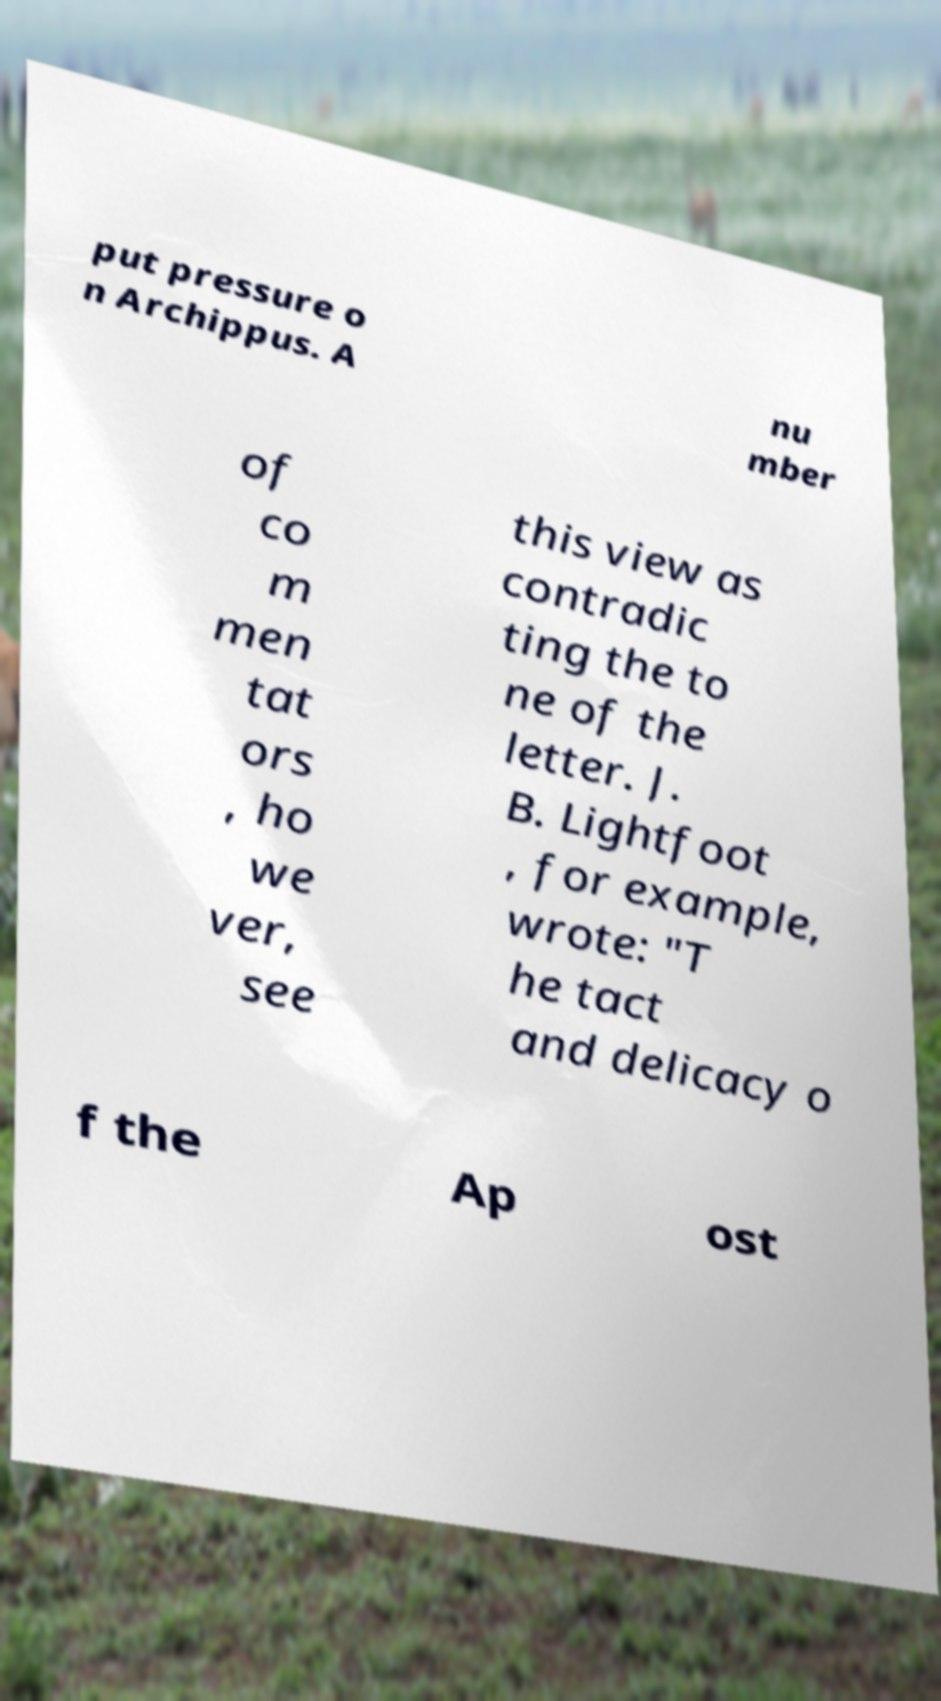Can you accurately transcribe the text from the provided image for me? put pressure o n Archippus. A nu mber of co m men tat ors , ho we ver, see this view as contradic ting the to ne of the letter. J. B. Lightfoot , for example, wrote: "T he tact and delicacy o f the Ap ost 